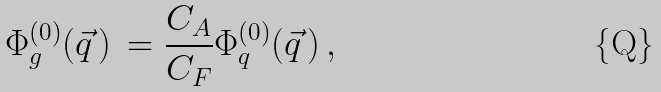Convert formula to latex. <formula><loc_0><loc_0><loc_500><loc_500>\Phi _ { g } ^ { ( 0 ) } ( \vec { q } \, ) \, = \frac { C _ { A } } { C _ { F } } \Phi _ { q } ^ { ( 0 ) } ( \vec { q } \, ) \, ,</formula> 